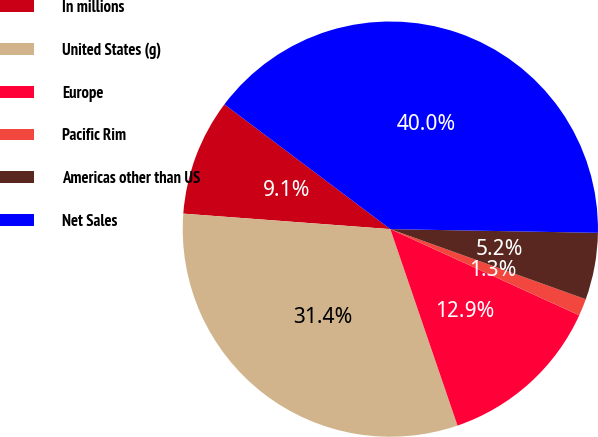Convert chart to OTSL. <chart><loc_0><loc_0><loc_500><loc_500><pie_chart><fcel>In millions<fcel>United States (g)<fcel>Europe<fcel>Pacific Rim<fcel>Americas other than US<fcel>Net Sales<nl><fcel>9.07%<fcel>31.43%<fcel>12.94%<fcel>1.33%<fcel>5.2%<fcel>40.02%<nl></chart> 